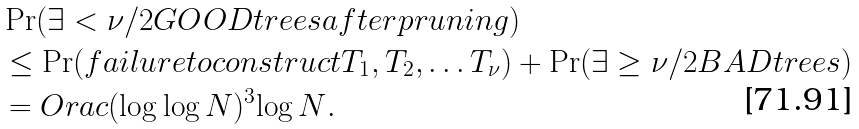<formula> <loc_0><loc_0><loc_500><loc_500>& \Pr ( \exists < \nu / 2 G O O D t r e e s a f t e r p r u n i n g ) \\ & \leq \Pr ( f a i l u r e t o c o n s t r u c t T _ { 1 } , T _ { 2 } , \dots T _ { \nu } ) + \Pr ( \exists \geq \nu / 2 B A D t r e e s ) \\ & = O r a c { ( \log \log N ) ^ { 3 } } { \log N } .</formula> 